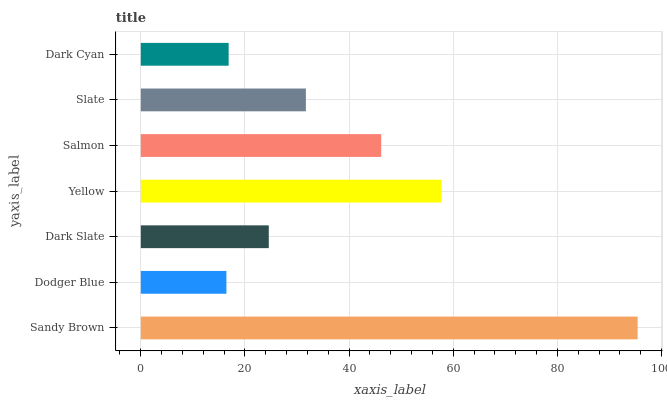Is Dodger Blue the minimum?
Answer yes or no. Yes. Is Sandy Brown the maximum?
Answer yes or no. Yes. Is Dark Slate the minimum?
Answer yes or no. No. Is Dark Slate the maximum?
Answer yes or no. No. Is Dark Slate greater than Dodger Blue?
Answer yes or no. Yes. Is Dodger Blue less than Dark Slate?
Answer yes or no. Yes. Is Dodger Blue greater than Dark Slate?
Answer yes or no. No. Is Dark Slate less than Dodger Blue?
Answer yes or no. No. Is Slate the high median?
Answer yes or no. Yes. Is Slate the low median?
Answer yes or no. Yes. Is Dark Cyan the high median?
Answer yes or no. No. Is Salmon the low median?
Answer yes or no. No. 